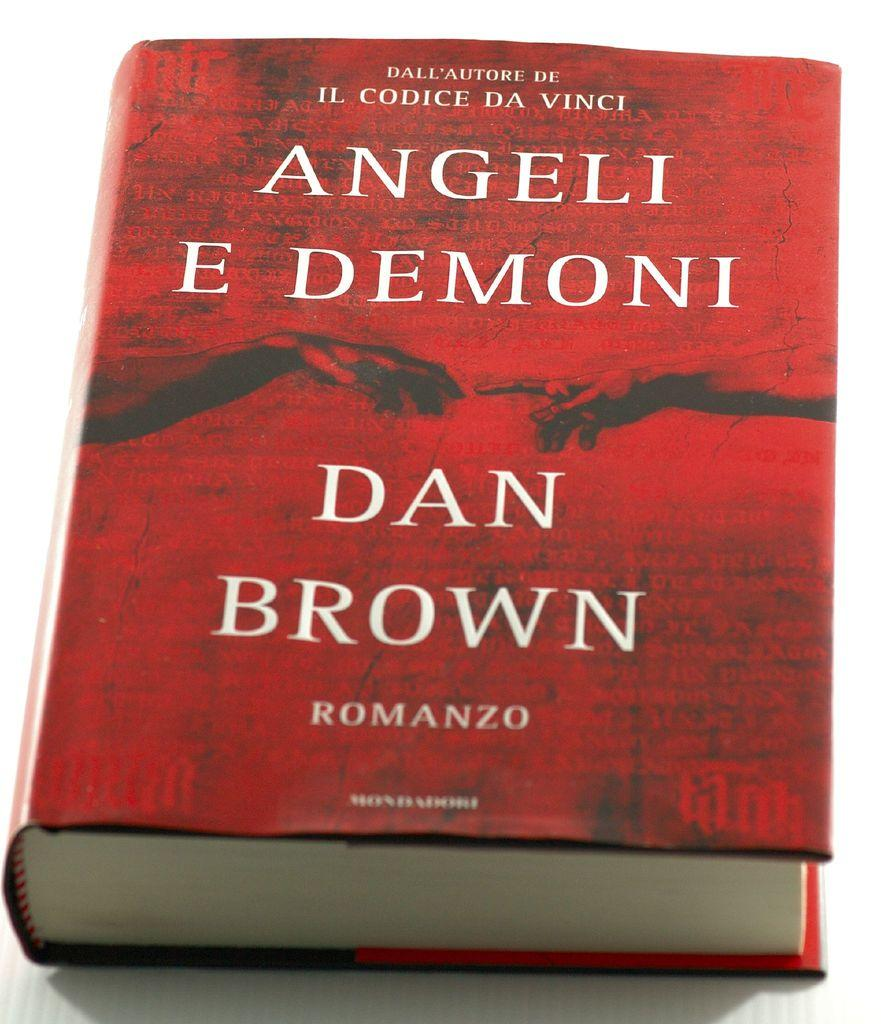<image>
Share a concise interpretation of the image provided. A red book titled Angeli E Demoni by Dan Brown. 